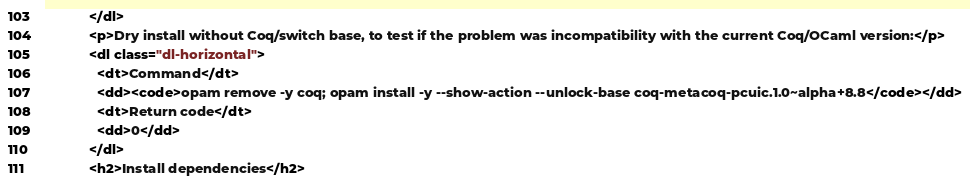<code> <loc_0><loc_0><loc_500><loc_500><_HTML_>            </dl>
            <p>Dry install without Coq/switch base, to test if the problem was incompatibility with the current Coq/OCaml version:</p>
            <dl class="dl-horizontal">
              <dt>Command</dt>
              <dd><code>opam remove -y coq; opam install -y --show-action --unlock-base coq-metacoq-pcuic.1.0~alpha+8.8</code></dd>
              <dt>Return code</dt>
              <dd>0</dd>
            </dl>
            <h2>Install dependencies</h2></code> 